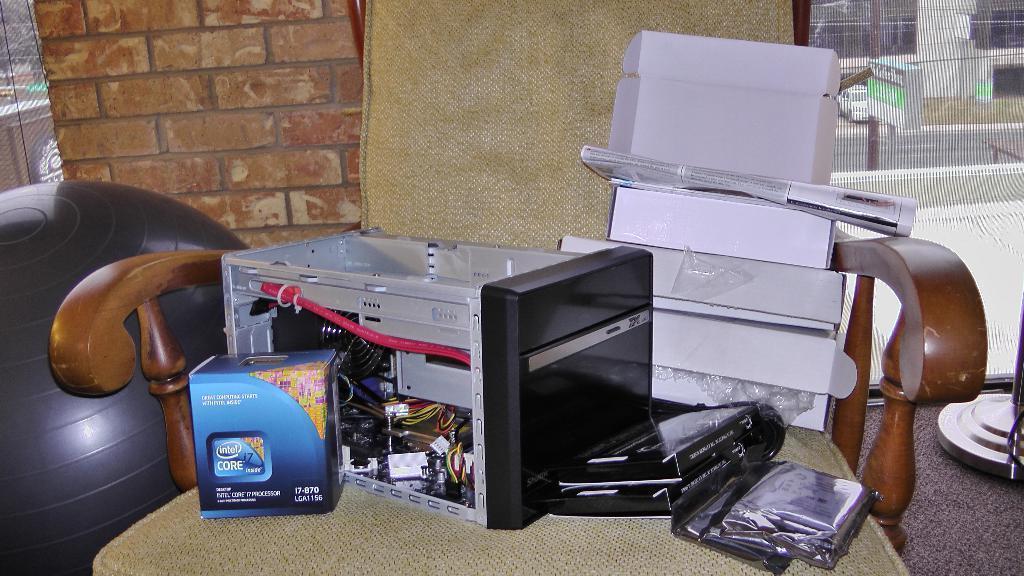Could you give a brief overview of what you see in this image? In the center of the image we can see books, printed and some objects placed on the chair. In the background we can see exercise ball, wall, vehicle, road and building. 